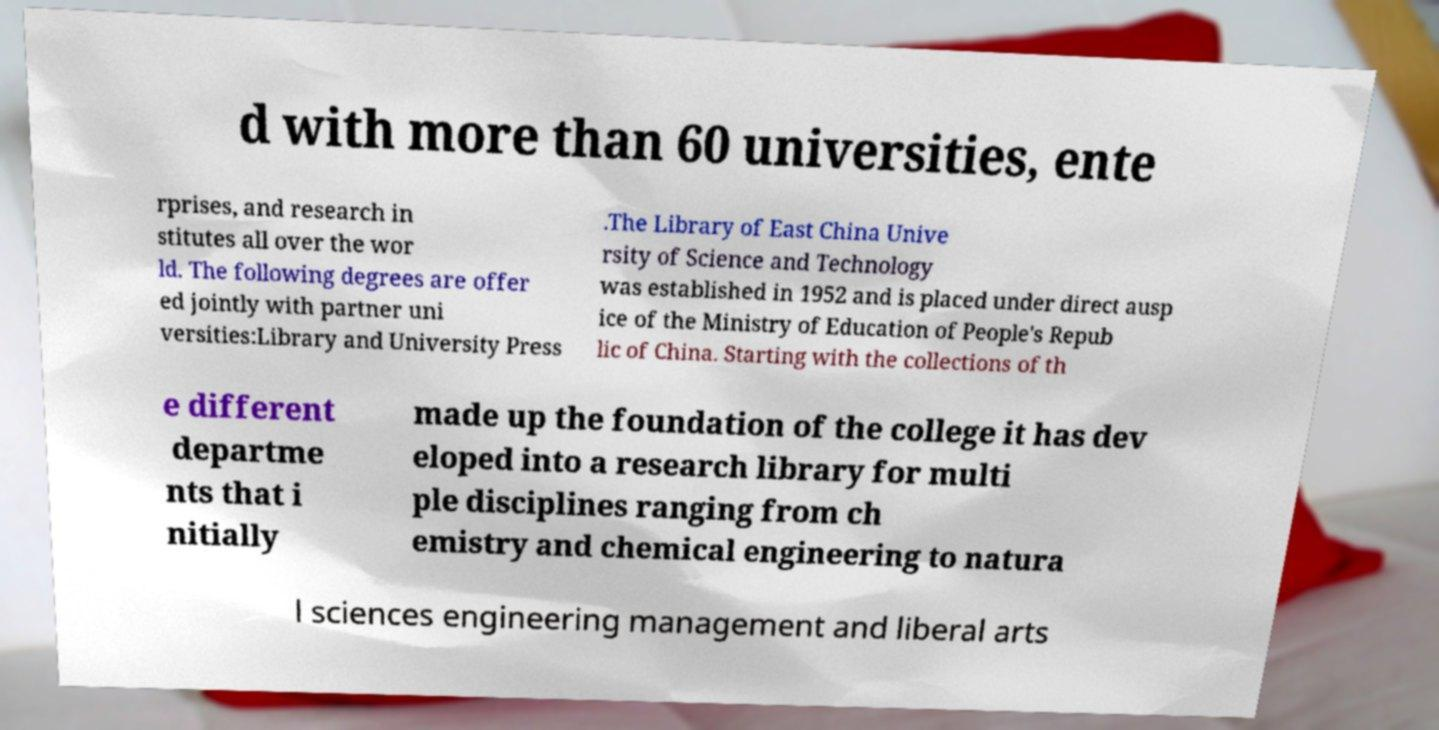There's text embedded in this image that I need extracted. Can you transcribe it verbatim? d with more than 60 universities, ente rprises, and research in stitutes all over the wor ld. The following degrees are offer ed jointly with partner uni versities:Library and University Press .The Library of East China Unive rsity of Science and Technology was established in 1952 and is placed under direct ausp ice of the Ministry of Education of People's Repub lic of China. Starting with the collections of th e different departme nts that i nitially made up the foundation of the college it has dev eloped into a research library for multi ple disciplines ranging from ch emistry and chemical engineering to natura l sciences engineering management and liberal arts 